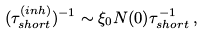Convert formula to latex. <formula><loc_0><loc_0><loc_500><loc_500>( \tau _ { s h o r t } ^ { ( i n h ) } ) ^ { - 1 } \sim \xi _ { 0 } N ( 0 ) \tau _ { s h o r t } ^ { - 1 } \, ,</formula> 